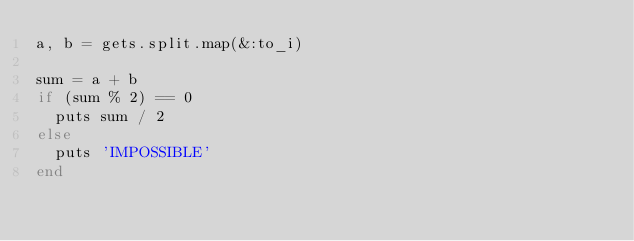Convert code to text. <code><loc_0><loc_0><loc_500><loc_500><_Ruby_>a, b = gets.split.map(&:to_i)

sum = a + b
if (sum % 2) == 0
  puts sum / 2
else
  puts 'IMPOSSIBLE'
end</code> 